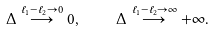Convert formula to latex. <formula><loc_0><loc_0><loc_500><loc_500>\Delta \stackrel { \ell _ { 1 } - \ell _ { 2 } \to 0 } { \longrightarrow } 0 , \quad \Delta \stackrel { \ell _ { 1 } - \ell _ { 2 } \to \infty } { \longrightarrow } + \infty .</formula> 